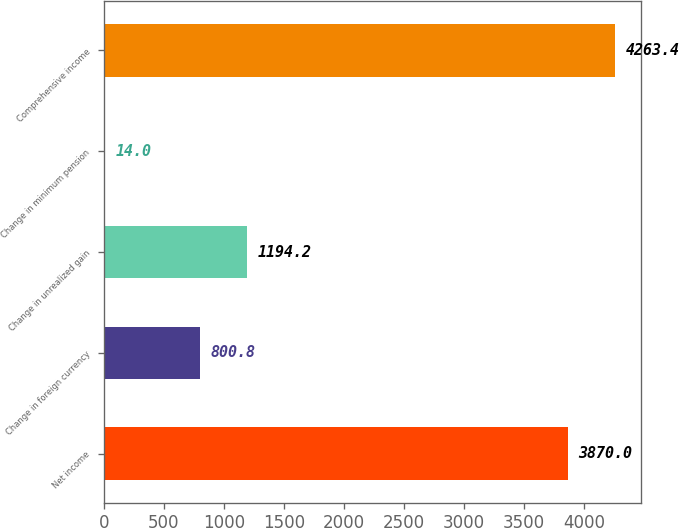<chart> <loc_0><loc_0><loc_500><loc_500><bar_chart><fcel>Net income<fcel>Change in foreign currency<fcel>Change in unrealized gain<fcel>Change in minimum pension<fcel>Comprehensive income<nl><fcel>3870<fcel>800.8<fcel>1194.2<fcel>14<fcel>4263.4<nl></chart> 